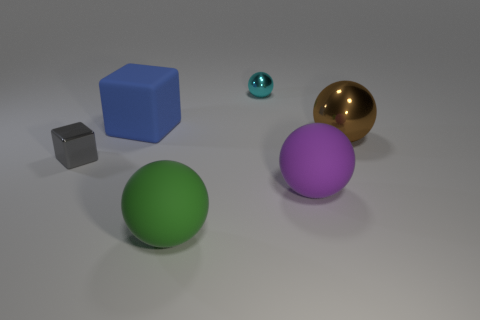Subtract all green matte spheres. How many spheres are left? 3 Add 2 purple metal cylinders. How many objects exist? 8 Subtract all blue spheres. Subtract all gray cubes. How many spheres are left? 4 Subtract all cubes. How many objects are left? 4 Subtract all tiny cyan things. Subtract all big blue metal cubes. How many objects are left? 5 Add 2 gray metallic blocks. How many gray metallic blocks are left? 3 Add 5 small yellow shiny balls. How many small yellow shiny balls exist? 5 Subtract 0 blue cylinders. How many objects are left? 6 